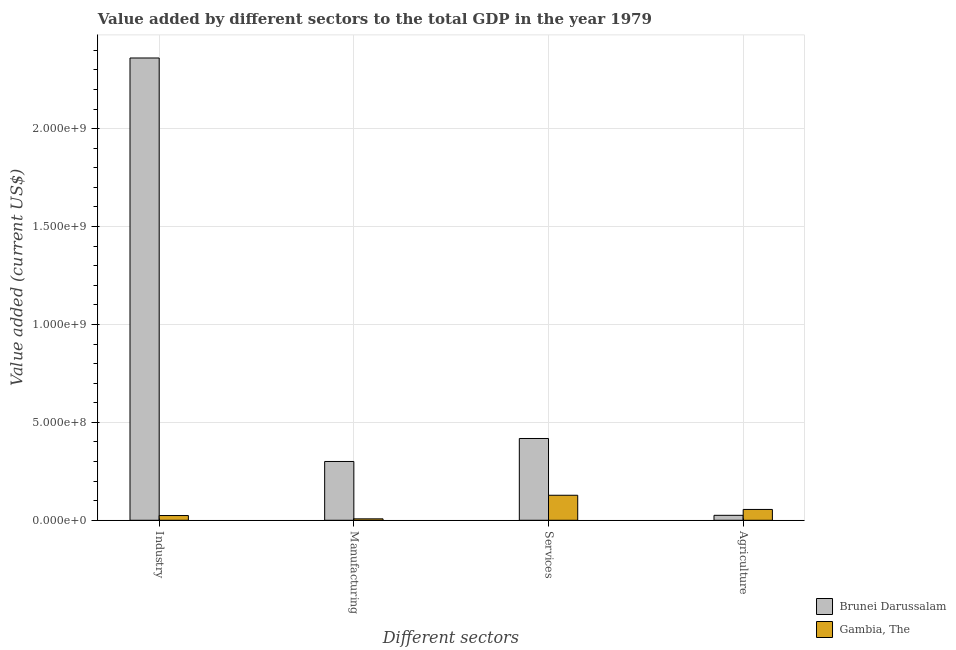Are the number of bars on each tick of the X-axis equal?
Ensure brevity in your answer.  Yes. How many bars are there on the 4th tick from the right?
Your response must be concise. 2. What is the label of the 2nd group of bars from the left?
Your answer should be compact. Manufacturing. What is the value added by manufacturing sector in Gambia, The?
Your response must be concise. 7.25e+06. Across all countries, what is the maximum value added by industrial sector?
Your answer should be compact. 2.36e+09. Across all countries, what is the minimum value added by manufacturing sector?
Your answer should be compact. 7.25e+06. In which country was the value added by services sector maximum?
Ensure brevity in your answer.  Brunei Darussalam. In which country was the value added by agricultural sector minimum?
Give a very brief answer. Brunei Darussalam. What is the total value added by manufacturing sector in the graph?
Keep it short and to the point. 3.08e+08. What is the difference between the value added by manufacturing sector in Brunei Darussalam and that in Gambia, The?
Offer a terse response. 2.93e+08. What is the difference between the value added by services sector in Brunei Darussalam and the value added by manufacturing sector in Gambia, The?
Provide a succinct answer. 4.10e+08. What is the average value added by agricultural sector per country?
Make the answer very short. 4.03e+07. What is the difference between the value added by services sector and value added by agricultural sector in Brunei Darussalam?
Ensure brevity in your answer.  3.92e+08. In how many countries, is the value added by services sector greater than 2100000000 US$?
Provide a short and direct response. 0. What is the ratio of the value added by services sector in Gambia, The to that in Brunei Darussalam?
Offer a very short reply. 0.31. Is the value added by manufacturing sector in Brunei Darussalam less than that in Gambia, The?
Your answer should be very brief. No. Is the difference between the value added by manufacturing sector in Gambia, The and Brunei Darussalam greater than the difference between the value added by industrial sector in Gambia, The and Brunei Darussalam?
Your response must be concise. Yes. What is the difference between the highest and the second highest value added by manufacturing sector?
Provide a succinct answer. 2.93e+08. What is the difference between the highest and the lowest value added by agricultural sector?
Your response must be concise. 3.00e+07. In how many countries, is the value added by industrial sector greater than the average value added by industrial sector taken over all countries?
Ensure brevity in your answer.  1. What does the 2nd bar from the left in Agriculture represents?
Your answer should be compact. Gambia, The. What does the 1st bar from the right in Agriculture represents?
Ensure brevity in your answer.  Gambia, The. How many bars are there?
Offer a terse response. 8. Are all the bars in the graph horizontal?
Your answer should be compact. No. How many countries are there in the graph?
Provide a short and direct response. 2. Does the graph contain any zero values?
Your response must be concise. No. Does the graph contain grids?
Offer a very short reply. Yes. How many legend labels are there?
Ensure brevity in your answer.  2. How are the legend labels stacked?
Ensure brevity in your answer.  Vertical. What is the title of the graph?
Offer a very short reply. Value added by different sectors to the total GDP in the year 1979. Does "High income: nonOECD" appear as one of the legend labels in the graph?
Provide a succinct answer. No. What is the label or title of the X-axis?
Provide a succinct answer. Different sectors. What is the label or title of the Y-axis?
Your response must be concise. Value added (current US$). What is the Value added (current US$) in Brunei Darussalam in Industry?
Provide a short and direct response. 2.36e+09. What is the Value added (current US$) in Gambia, The in Industry?
Keep it short and to the point. 2.41e+07. What is the Value added (current US$) in Brunei Darussalam in Manufacturing?
Offer a very short reply. 3.00e+08. What is the Value added (current US$) of Gambia, The in Manufacturing?
Offer a very short reply. 7.25e+06. What is the Value added (current US$) of Brunei Darussalam in Services?
Provide a short and direct response. 4.18e+08. What is the Value added (current US$) of Gambia, The in Services?
Make the answer very short. 1.28e+08. What is the Value added (current US$) of Brunei Darussalam in Agriculture?
Give a very brief answer. 2.53e+07. What is the Value added (current US$) of Gambia, The in Agriculture?
Provide a short and direct response. 5.53e+07. Across all Different sectors, what is the maximum Value added (current US$) of Brunei Darussalam?
Keep it short and to the point. 2.36e+09. Across all Different sectors, what is the maximum Value added (current US$) in Gambia, The?
Your answer should be compact. 1.28e+08. Across all Different sectors, what is the minimum Value added (current US$) of Brunei Darussalam?
Your response must be concise. 2.53e+07. Across all Different sectors, what is the minimum Value added (current US$) in Gambia, The?
Make the answer very short. 7.25e+06. What is the total Value added (current US$) of Brunei Darussalam in the graph?
Offer a terse response. 3.10e+09. What is the total Value added (current US$) of Gambia, The in the graph?
Make the answer very short. 2.14e+08. What is the difference between the Value added (current US$) in Brunei Darussalam in Industry and that in Manufacturing?
Ensure brevity in your answer.  2.06e+09. What is the difference between the Value added (current US$) in Gambia, The in Industry and that in Manufacturing?
Offer a terse response. 1.69e+07. What is the difference between the Value added (current US$) in Brunei Darussalam in Industry and that in Services?
Your response must be concise. 1.94e+09. What is the difference between the Value added (current US$) of Gambia, The in Industry and that in Services?
Your answer should be compact. -1.04e+08. What is the difference between the Value added (current US$) of Brunei Darussalam in Industry and that in Agriculture?
Offer a terse response. 2.34e+09. What is the difference between the Value added (current US$) of Gambia, The in Industry and that in Agriculture?
Provide a short and direct response. -3.12e+07. What is the difference between the Value added (current US$) of Brunei Darussalam in Manufacturing and that in Services?
Give a very brief answer. -1.17e+08. What is the difference between the Value added (current US$) of Gambia, The in Manufacturing and that in Services?
Give a very brief answer. -1.20e+08. What is the difference between the Value added (current US$) of Brunei Darussalam in Manufacturing and that in Agriculture?
Keep it short and to the point. 2.75e+08. What is the difference between the Value added (current US$) of Gambia, The in Manufacturing and that in Agriculture?
Provide a succinct answer. -4.80e+07. What is the difference between the Value added (current US$) of Brunei Darussalam in Services and that in Agriculture?
Offer a terse response. 3.92e+08. What is the difference between the Value added (current US$) in Gambia, The in Services and that in Agriculture?
Offer a terse response. 7.24e+07. What is the difference between the Value added (current US$) in Brunei Darussalam in Industry and the Value added (current US$) in Gambia, The in Manufacturing?
Your answer should be compact. 2.35e+09. What is the difference between the Value added (current US$) in Brunei Darussalam in Industry and the Value added (current US$) in Gambia, The in Services?
Offer a terse response. 2.23e+09. What is the difference between the Value added (current US$) of Brunei Darussalam in Industry and the Value added (current US$) of Gambia, The in Agriculture?
Provide a short and direct response. 2.31e+09. What is the difference between the Value added (current US$) in Brunei Darussalam in Manufacturing and the Value added (current US$) in Gambia, The in Services?
Make the answer very short. 1.73e+08. What is the difference between the Value added (current US$) of Brunei Darussalam in Manufacturing and the Value added (current US$) of Gambia, The in Agriculture?
Your response must be concise. 2.45e+08. What is the difference between the Value added (current US$) in Brunei Darussalam in Services and the Value added (current US$) in Gambia, The in Agriculture?
Your answer should be very brief. 3.62e+08. What is the average Value added (current US$) of Brunei Darussalam per Different sectors?
Provide a short and direct response. 7.76e+08. What is the average Value added (current US$) of Gambia, The per Different sectors?
Ensure brevity in your answer.  5.36e+07. What is the difference between the Value added (current US$) of Brunei Darussalam and Value added (current US$) of Gambia, The in Industry?
Make the answer very short. 2.34e+09. What is the difference between the Value added (current US$) in Brunei Darussalam and Value added (current US$) in Gambia, The in Manufacturing?
Provide a succinct answer. 2.93e+08. What is the difference between the Value added (current US$) of Brunei Darussalam and Value added (current US$) of Gambia, The in Services?
Give a very brief answer. 2.90e+08. What is the difference between the Value added (current US$) in Brunei Darussalam and Value added (current US$) in Gambia, The in Agriculture?
Your answer should be very brief. -3.00e+07. What is the ratio of the Value added (current US$) of Brunei Darussalam in Industry to that in Manufacturing?
Give a very brief answer. 7.86. What is the ratio of the Value added (current US$) of Gambia, The in Industry to that in Manufacturing?
Your answer should be very brief. 3.32. What is the ratio of the Value added (current US$) in Brunei Darussalam in Industry to that in Services?
Offer a very short reply. 5.65. What is the ratio of the Value added (current US$) of Gambia, The in Industry to that in Services?
Give a very brief answer. 0.19. What is the ratio of the Value added (current US$) in Brunei Darussalam in Industry to that in Agriculture?
Give a very brief answer. 93.35. What is the ratio of the Value added (current US$) of Gambia, The in Industry to that in Agriculture?
Keep it short and to the point. 0.44. What is the ratio of the Value added (current US$) in Brunei Darussalam in Manufacturing to that in Services?
Your response must be concise. 0.72. What is the ratio of the Value added (current US$) in Gambia, The in Manufacturing to that in Services?
Make the answer very short. 0.06. What is the ratio of the Value added (current US$) of Brunei Darussalam in Manufacturing to that in Agriculture?
Provide a succinct answer. 11.87. What is the ratio of the Value added (current US$) of Gambia, The in Manufacturing to that in Agriculture?
Keep it short and to the point. 0.13. What is the ratio of the Value added (current US$) of Brunei Darussalam in Services to that in Agriculture?
Make the answer very short. 16.51. What is the ratio of the Value added (current US$) of Gambia, The in Services to that in Agriculture?
Offer a very short reply. 2.31. What is the difference between the highest and the second highest Value added (current US$) in Brunei Darussalam?
Make the answer very short. 1.94e+09. What is the difference between the highest and the second highest Value added (current US$) of Gambia, The?
Keep it short and to the point. 7.24e+07. What is the difference between the highest and the lowest Value added (current US$) in Brunei Darussalam?
Provide a succinct answer. 2.34e+09. What is the difference between the highest and the lowest Value added (current US$) in Gambia, The?
Ensure brevity in your answer.  1.20e+08. 